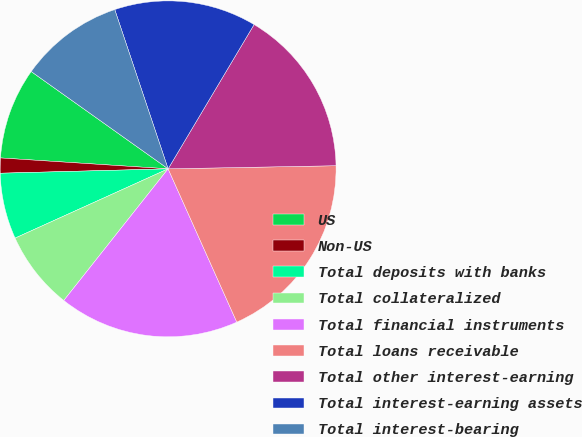Convert chart to OTSL. <chart><loc_0><loc_0><loc_500><loc_500><pie_chart><fcel>US<fcel>Non-US<fcel>Total deposits with banks<fcel>Total collateralized<fcel>Total financial instruments<fcel>Total loans receivable<fcel>Total other interest-earning<fcel>Total interest-earning assets<fcel>Total interest-bearing<nl><fcel>8.8%<fcel>1.45%<fcel>6.35%<fcel>7.57%<fcel>17.37%<fcel>18.59%<fcel>16.15%<fcel>13.7%<fcel>10.02%<nl></chart> 